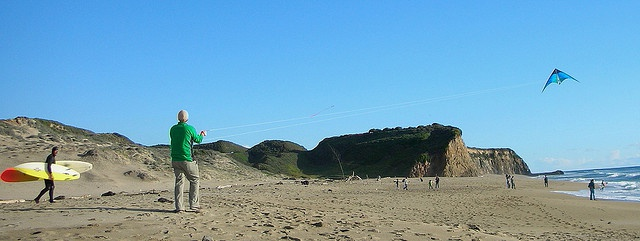Describe the objects in this image and their specific colors. I can see people in gray, darkgreen, black, and darkgray tones, surfboard in gray, beige, khaki, and olive tones, people in gray, black, darkgray, and maroon tones, surfboard in gray, brown, maroon, olive, and salmon tones, and surfboard in gray, beige, and tan tones in this image. 